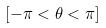Convert formula to latex. <formula><loc_0><loc_0><loc_500><loc_500>[ - \pi < \theta < \pi ]</formula> 